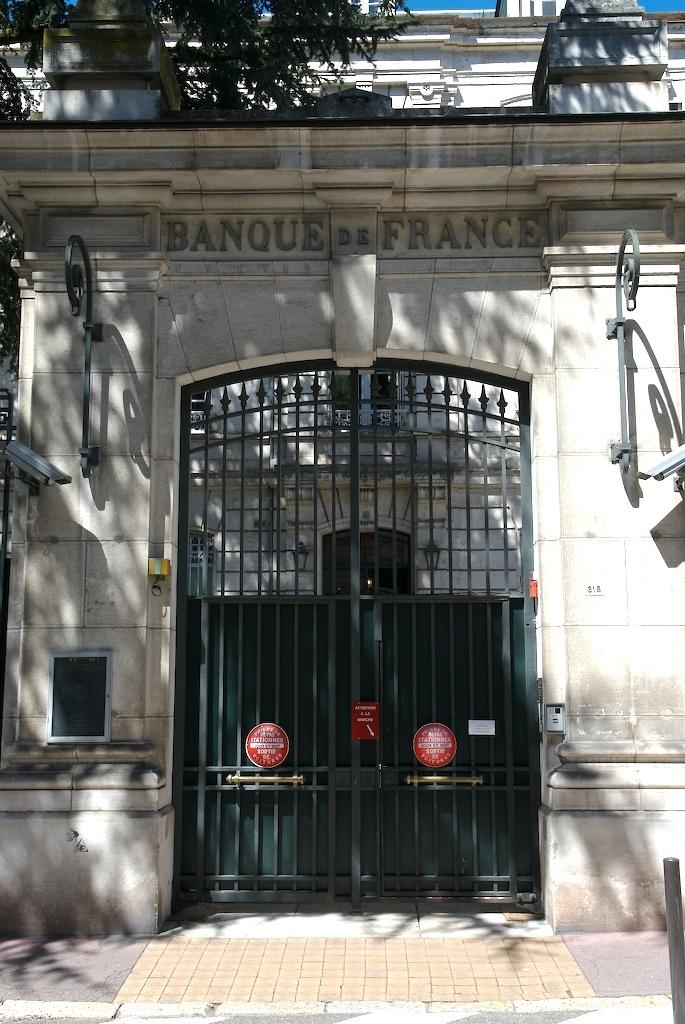What type of structure is present in the image? There is a building in the image. What feature can be seen on the building? The building has a metal gate. What can be found on a wall in the image? There is text on a wall in the image. What type of vegetation is visible at the top of the image? There is a tree visible at the top of the image. What else is visible at the top of the image? The sky is visible at the top of the image. How does the building pull itself along the ground in the image? The building does not move or pull itself along the ground in the image; it is stationary. 